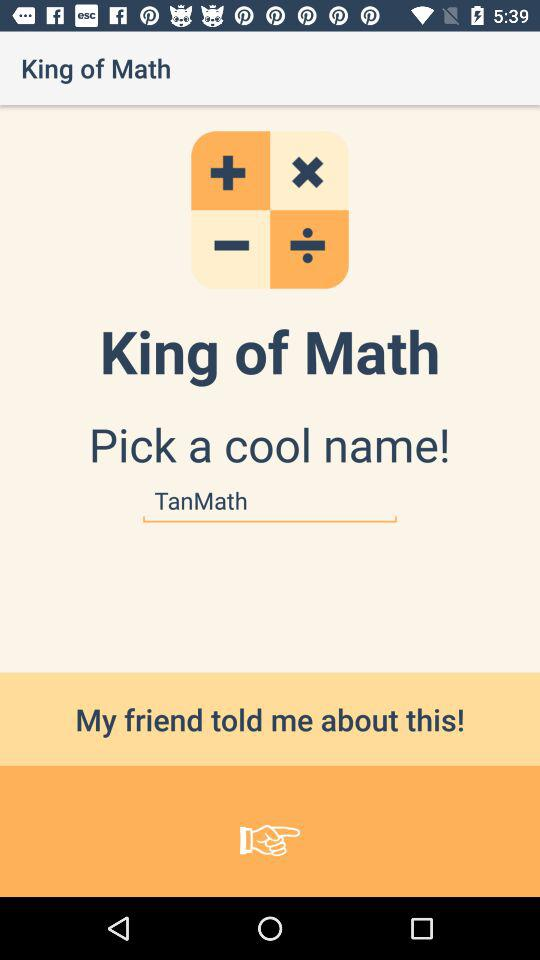How many math operators are there?
Answer the question using a single word or phrase. 4 